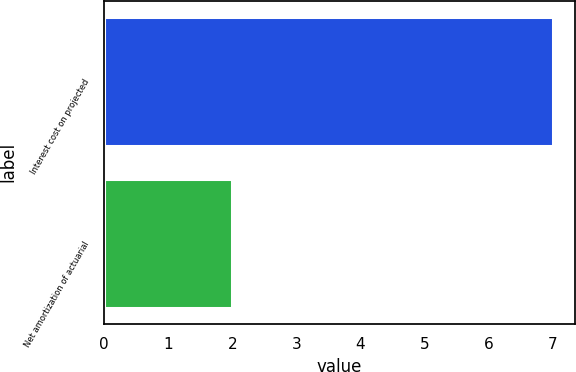Convert chart to OTSL. <chart><loc_0><loc_0><loc_500><loc_500><bar_chart><fcel>Interest cost on projected<fcel>Net amortization of actuarial<nl><fcel>7<fcel>2<nl></chart> 